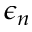<formula> <loc_0><loc_0><loc_500><loc_500>\epsilon _ { n }</formula> 